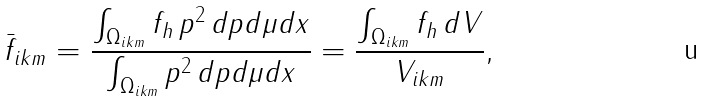<formula> <loc_0><loc_0><loc_500><loc_500>\bar { f } _ { i k m } = \frac { \int _ { \Omega _ { i k m } } f _ { h } \, p ^ { 2 } \, d p d \mu d x } { \int _ { \Omega _ { i k m } } p ^ { 2 } \, d p d \mu d x } = \frac { \int _ { \Omega _ { i k m } } f _ { h } \, d V } { V _ { i k m } } , \,</formula> 